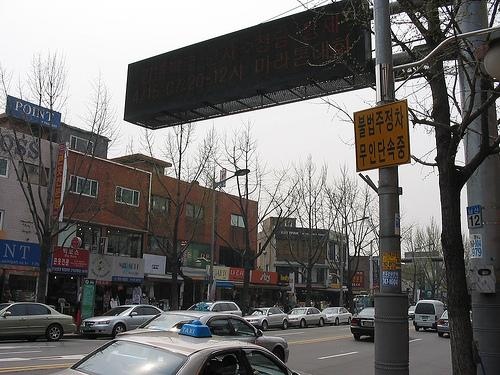State the number of moving cars and their colors. There are five moving cars, but their colors are not explicitly mentioned. List the number of cars in the image and their colors. There are six cars parked on the street, including a black car, a silver car, and a white van. 